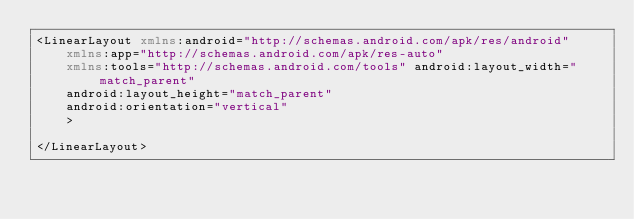<code> <loc_0><loc_0><loc_500><loc_500><_XML_><LinearLayout xmlns:android="http://schemas.android.com/apk/res/android"
    xmlns:app="http://schemas.android.com/apk/res-auto"
    xmlns:tools="http://schemas.android.com/tools" android:layout_width="match_parent"
    android:layout_height="match_parent"
    android:orientation="vertical"
    >

</LinearLayout>
</code> 